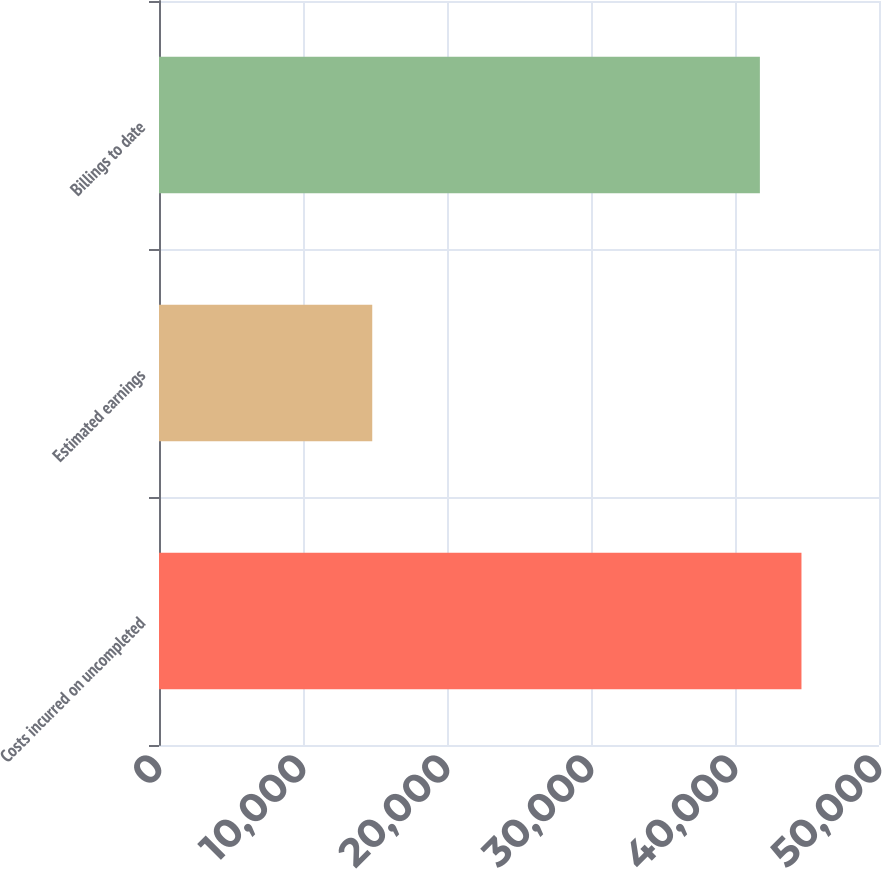Convert chart to OTSL. <chart><loc_0><loc_0><loc_500><loc_500><bar_chart><fcel>Costs incurred on uncompleted<fcel>Estimated earnings<fcel>Billings to date<nl><fcel>44615.7<fcel>14809<fcel>41728<nl></chart> 